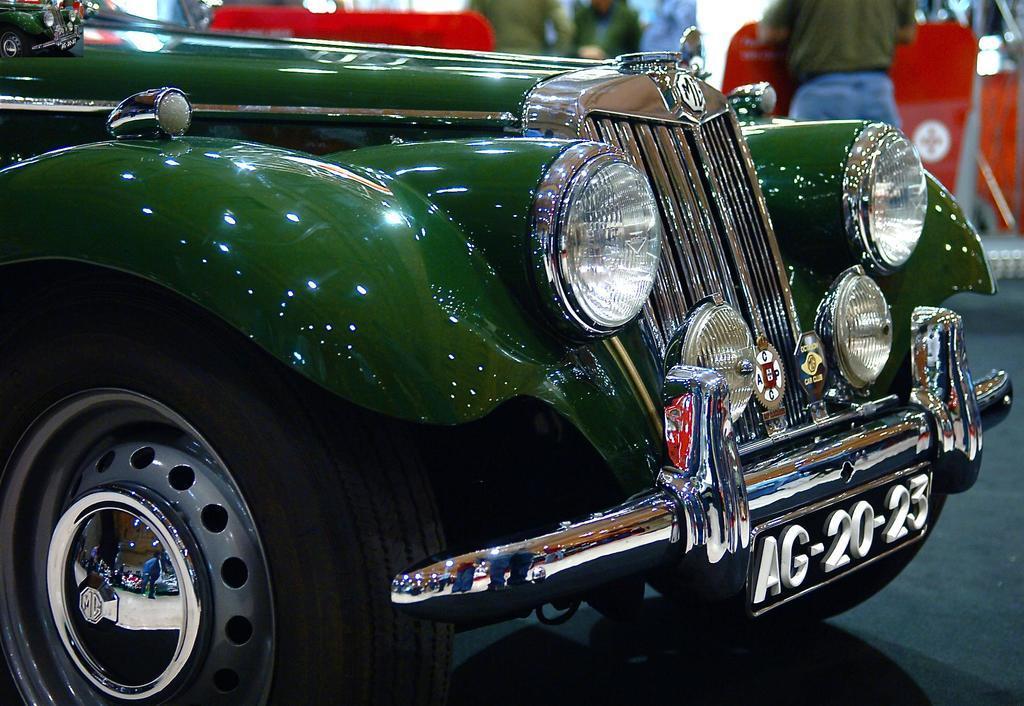Can you describe this image briefly? In this image I can see a green colour vehicle and here I can see something is written. I can also see few people in background and I can see this image is little bit blurry from background. 